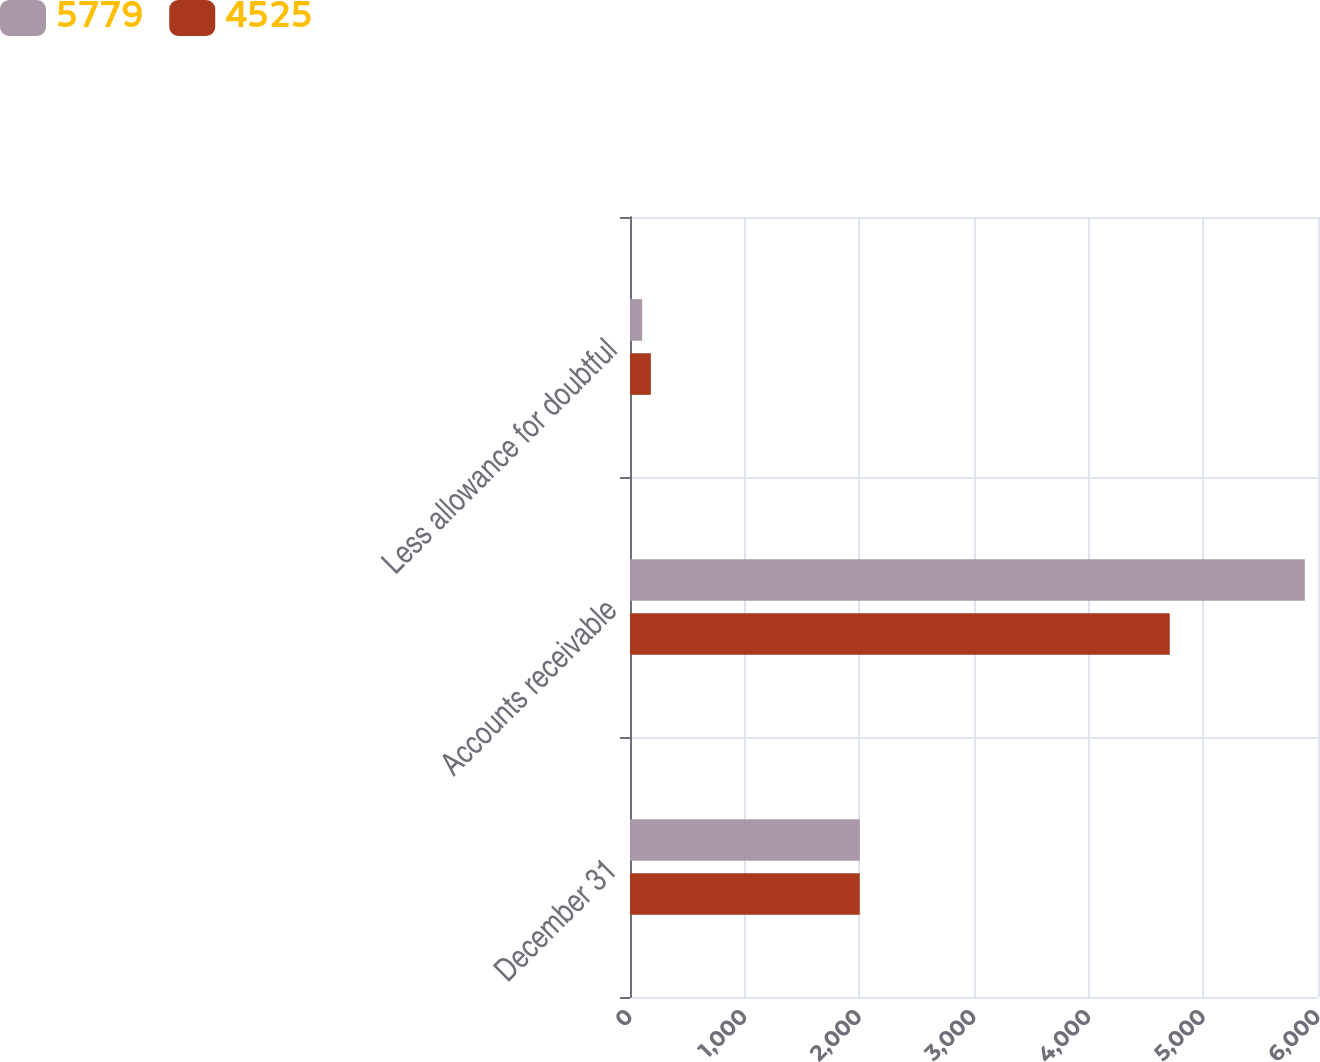Convert chart. <chart><loc_0><loc_0><loc_500><loc_500><stacked_bar_chart><ecel><fcel>December 31<fcel>Accounts receivable<fcel>Less allowance for doubtful<nl><fcel>5779<fcel>2005<fcel>5885<fcel>106<nl><fcel>4525<fcel>2004<fcel>4707<fcel>182<nl></chart> 